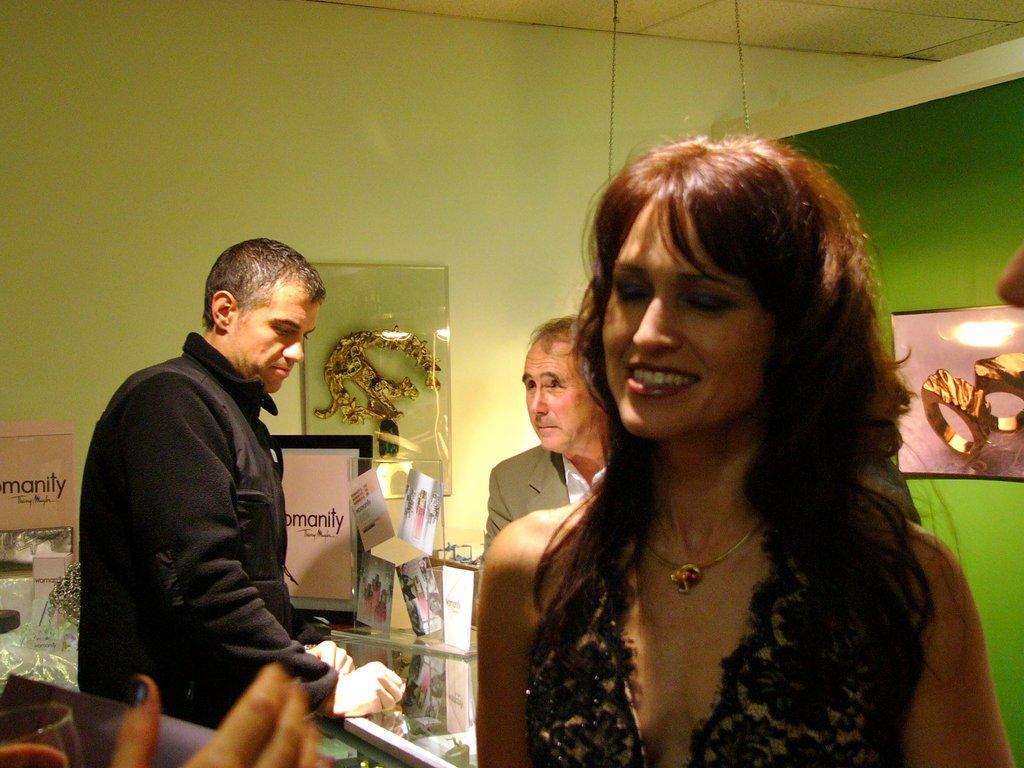Can you describe this image briefly? In the picture we can see a woman standing and smiling and behind her we can see two men are also standing near the glass desk and behind them we can see a wall with something are placed to it. 